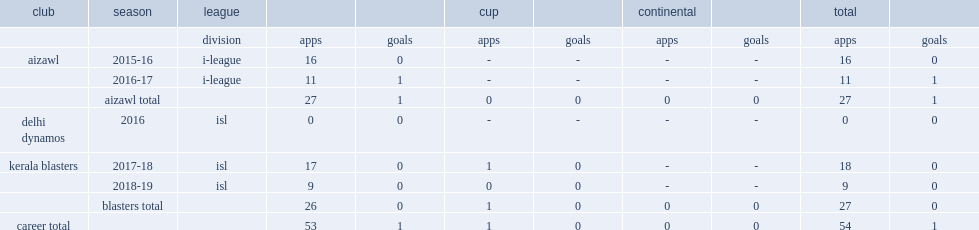Which club in the 2016-17 i-league did lalruatthara appear with? Aizawl. 